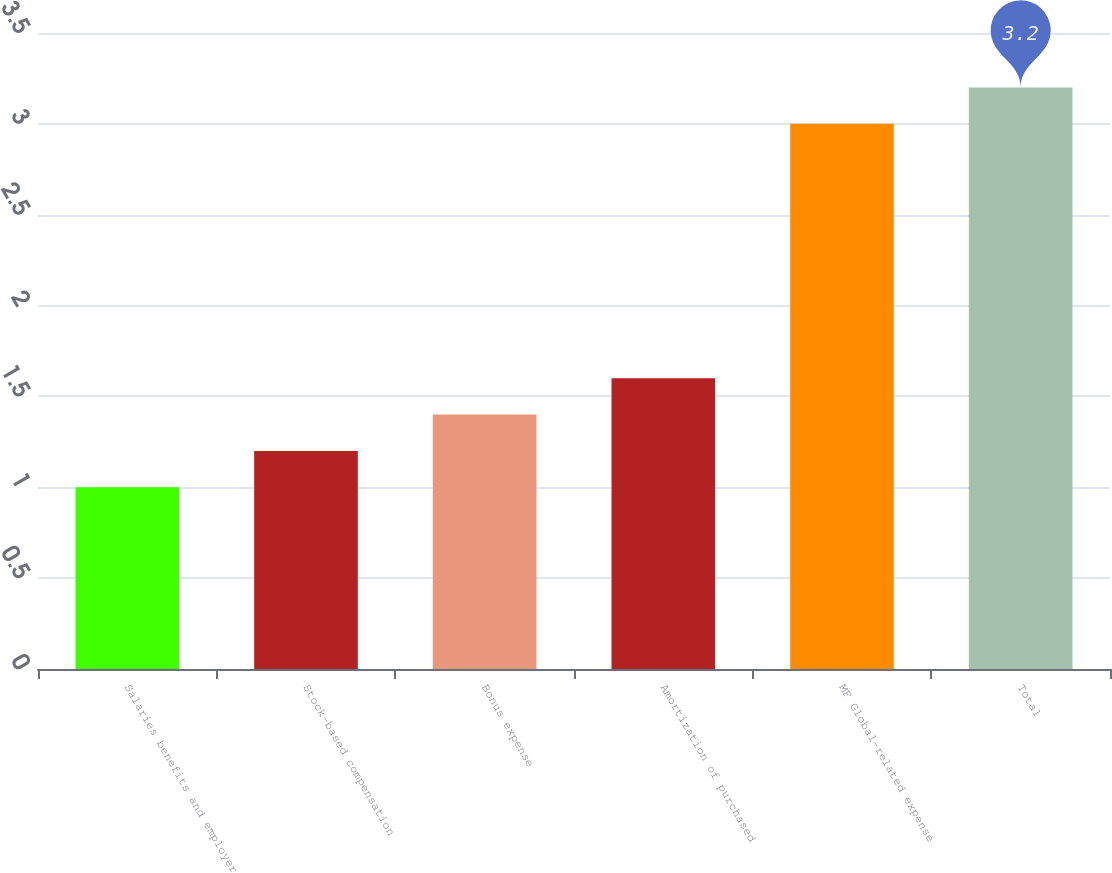Convert chart. <chart><loc_0><loc_0><loc_500><loc_500><bar_chart><fcel>Salaries benefits and employer<fcel>Stock-based compensation<fcel>Bonus expense<fcel>Amortization of purchased<fcel>MF Global-related expense<fcel>Total<nl><fcel>1<fcel>1.2<fcel>1.4<fcel>1.6<fcel>3<fcel>3.2<nl></chart> 